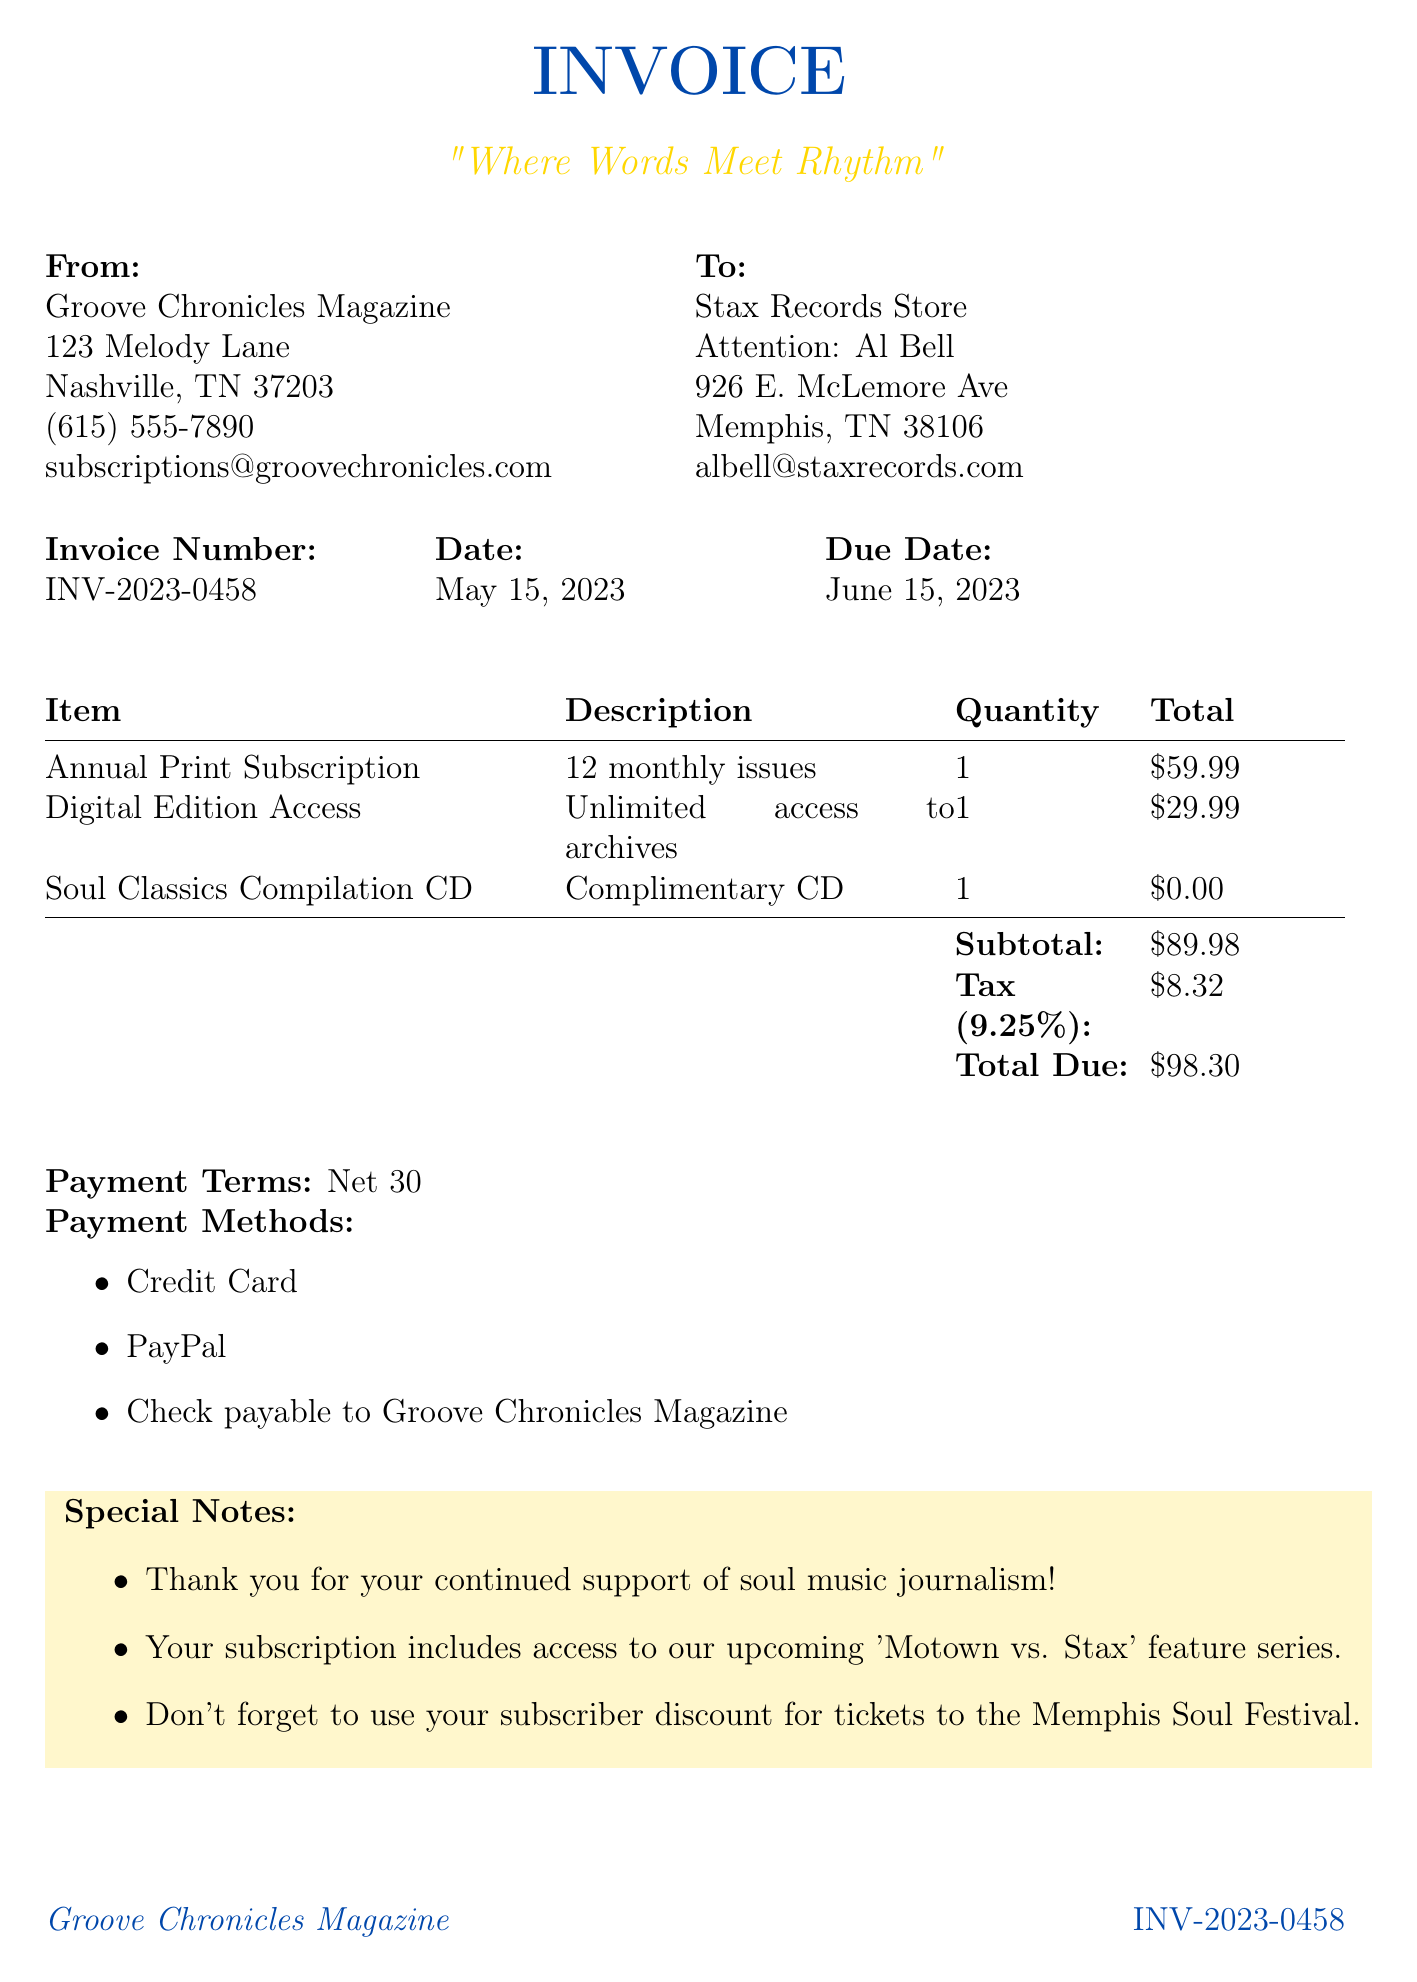What is the invoice number? The invoice number is a unique identifier for this transaction and is listed in the document.
Answer: INV-2023-0458 What is the date of the invoice? The date marks when the invoice was created, found under the invoice details.
Answer: May 15, 2023 What is the total due amount? The total due amount is the final price that needs to be paid, including tax.
Answer: $98.30 What is the tax rate applied in the invoice? The tax rate is mentioned in the breakdown section of the invoice and affects the total calculation.
Answer: 9.25% Who is the attention designation in the recipient details? The attention designation indicates the person to whom the invoice is addressed at the recipient's company.
Answer: Al Bell How many monthly issues are included in the print subscription? The number of monthly issues is specified in the item description on the invoice.
Answer: 12 What special note is included about the Memphis Soul Festival? The special note relates to an event that subscribers can enjoy, highlighting the benefit of the subscription.
Answer: Subscriber discount for tickets What payment terms are mentioned in the document? Payment terms specify the timeframe within which the payment should be made according to the invoice.
Answer: Net 30 What item comes complimentary with the subscription? The complimentary item is mentioned as part of the subscription details.
Answer: Soul Classics Compilation CD 